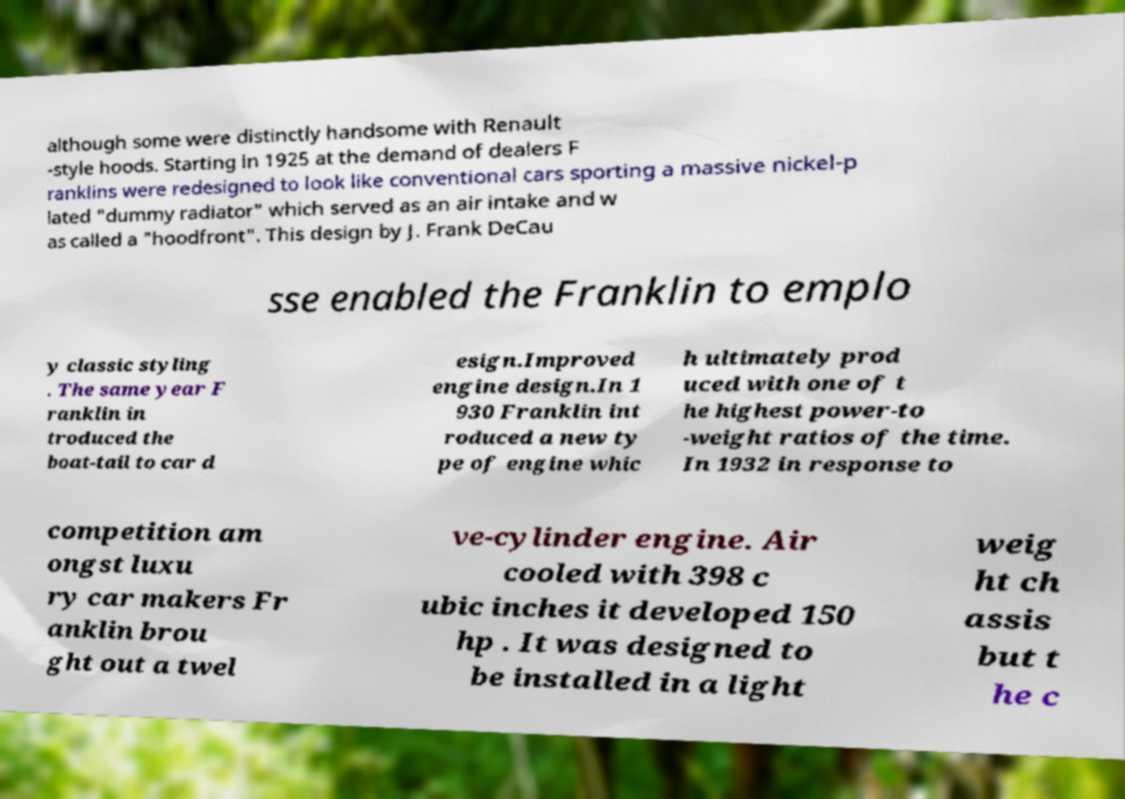What messages or text are displayed in this image? I need them in a readable, typed format. although some were distinctly handsome with Renault -style hoods. Starting in 1925 at the demand of dealers F ranklins were redesigned to look like conventional cars sporting a massive nickel-p lated "dummy radiator" which served as an air intake and w as called a "hoodfront". This design by J. Frank DeCau sse enabled the Franklin to emplo y classic styling . The same year F ranklin in troduced the boat-tail to car d esign.Improved engine design.In 1 930 Franklin int roduced a new ty pe of engine whic h ultimately prod uced with one of t he highest power-to -weight ratios of the time. In 1932 in response to competition am ongst luxu ry car makers Fr anklin brou ght out a twel ve-cylinder engine. Air cooled with 398 c ubic inches it developed 150 hp . It was designed to be installed in a light weig ht ch assis but t he c 